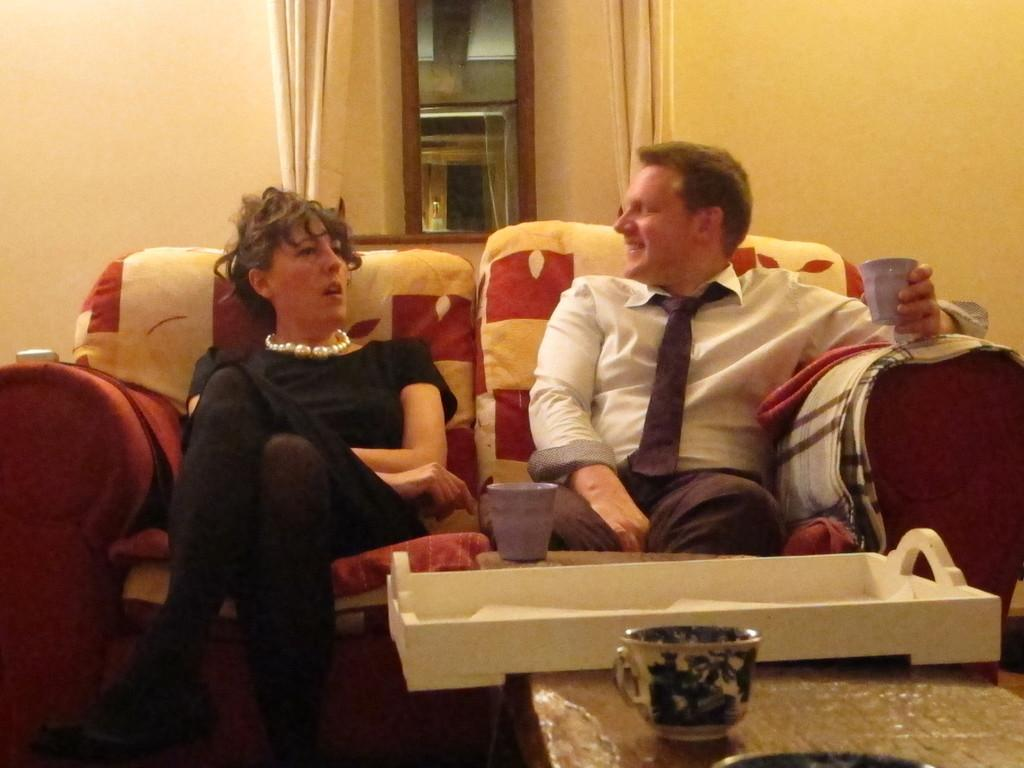How many people are in the image? There is a man and a woman in the image. What are they doing in the image? Both the man and woman are sitting in a sofa chair. What is on the table in front of them? There is a tray on a table in front of them. What can be seen on the tray? There is a cup on the table. What is visible in the background of the image? There is a bowl and a curtain in the background of the image. What type of underwear is the man wearing in the image? There is no information about the man's underwear in the image, and therefore it cannot be determined. 